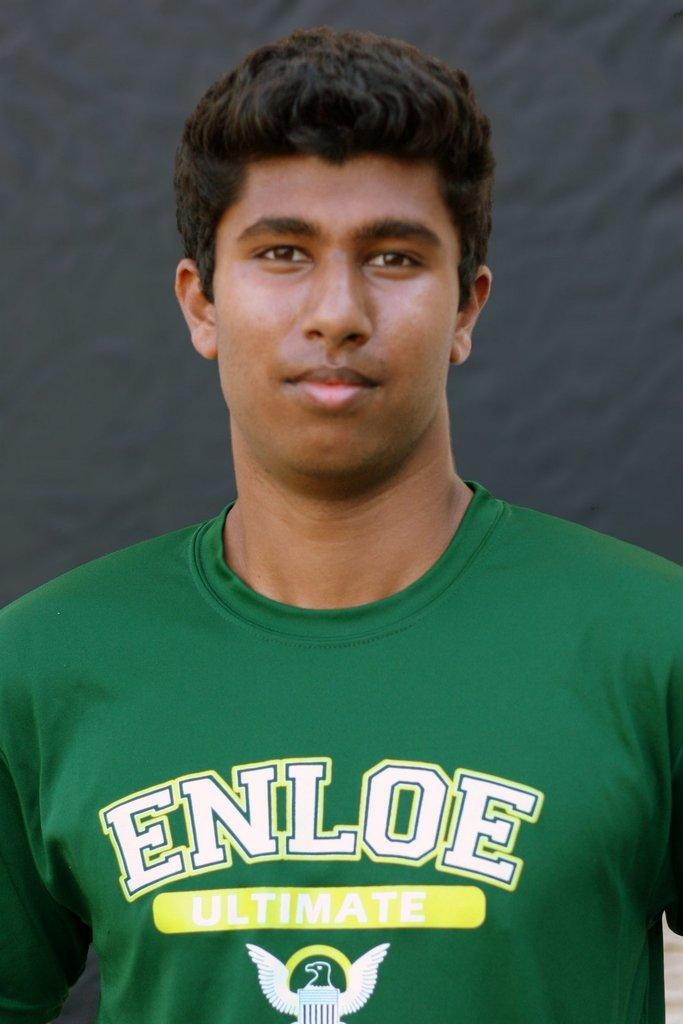<image>
Write a terse but informative summary of the picture. A man in a green Enloe shirt smiles for a picture. 